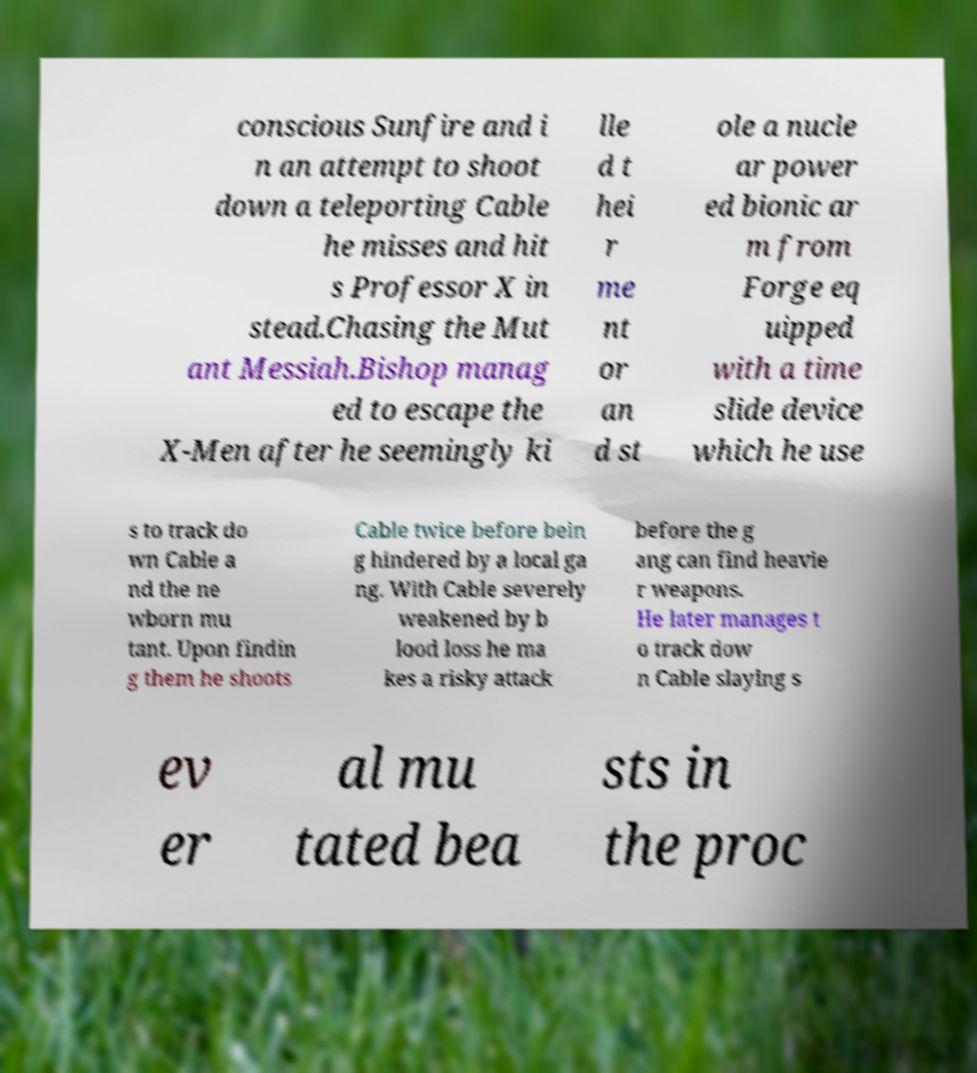Can you accurately transcribe the text from the provided image for me? conscious Sunfire and i n an attempt to shoot down a teleporting Cable he misses and hit s Professor X in stead.Chasing the Mut ant Messiah.Bishop manag ed to escape the X-Men after he seemingly ki lle d t hei r me nt or an d st ole a nucle ar power ed bionic ar m from Forge eq uipped with a time slide device which he use s to track do wn Cable a nd the ne wborn mu tant. Upon findin g them he shoots Cable twice before bein g hindered by a local ga ng. With Cable severely weakened by b lood loss he ma kes a risky attack before the g ang can find heavie r weapons. He later manages t o track dow n Cable slaying s ev er al mu tated bea sts in the proc 